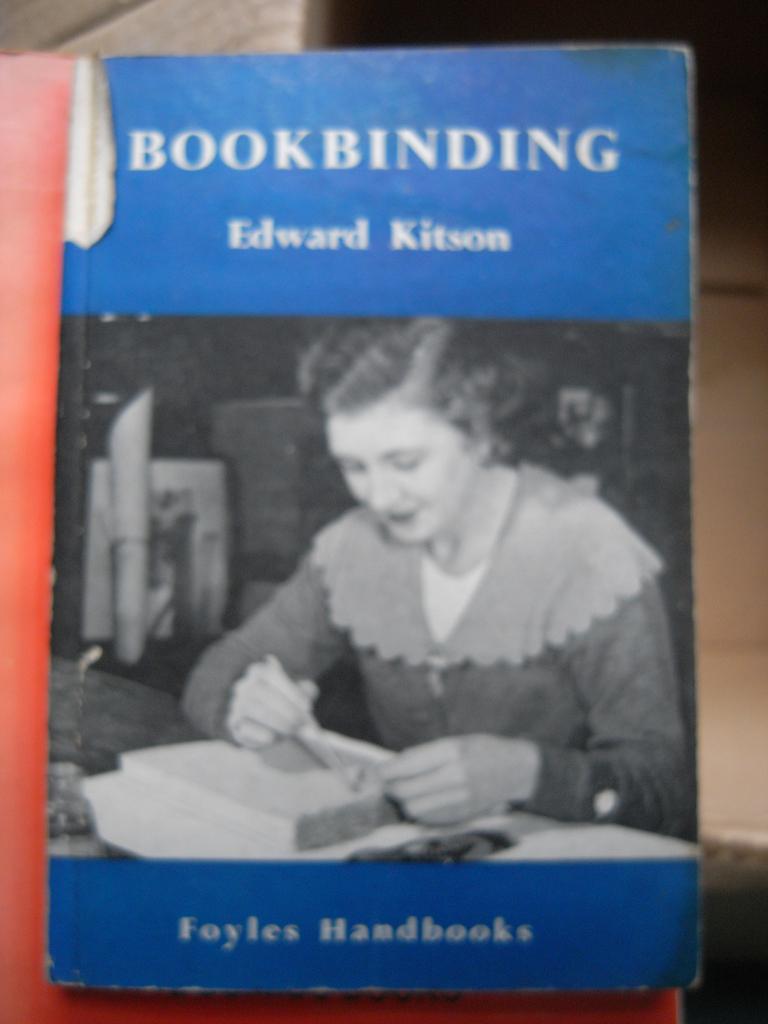What is this book about?
Provide a short and direct response. Bookbinding. Who is the author of the book?
Keep it short and to the point. Edward kitson. 